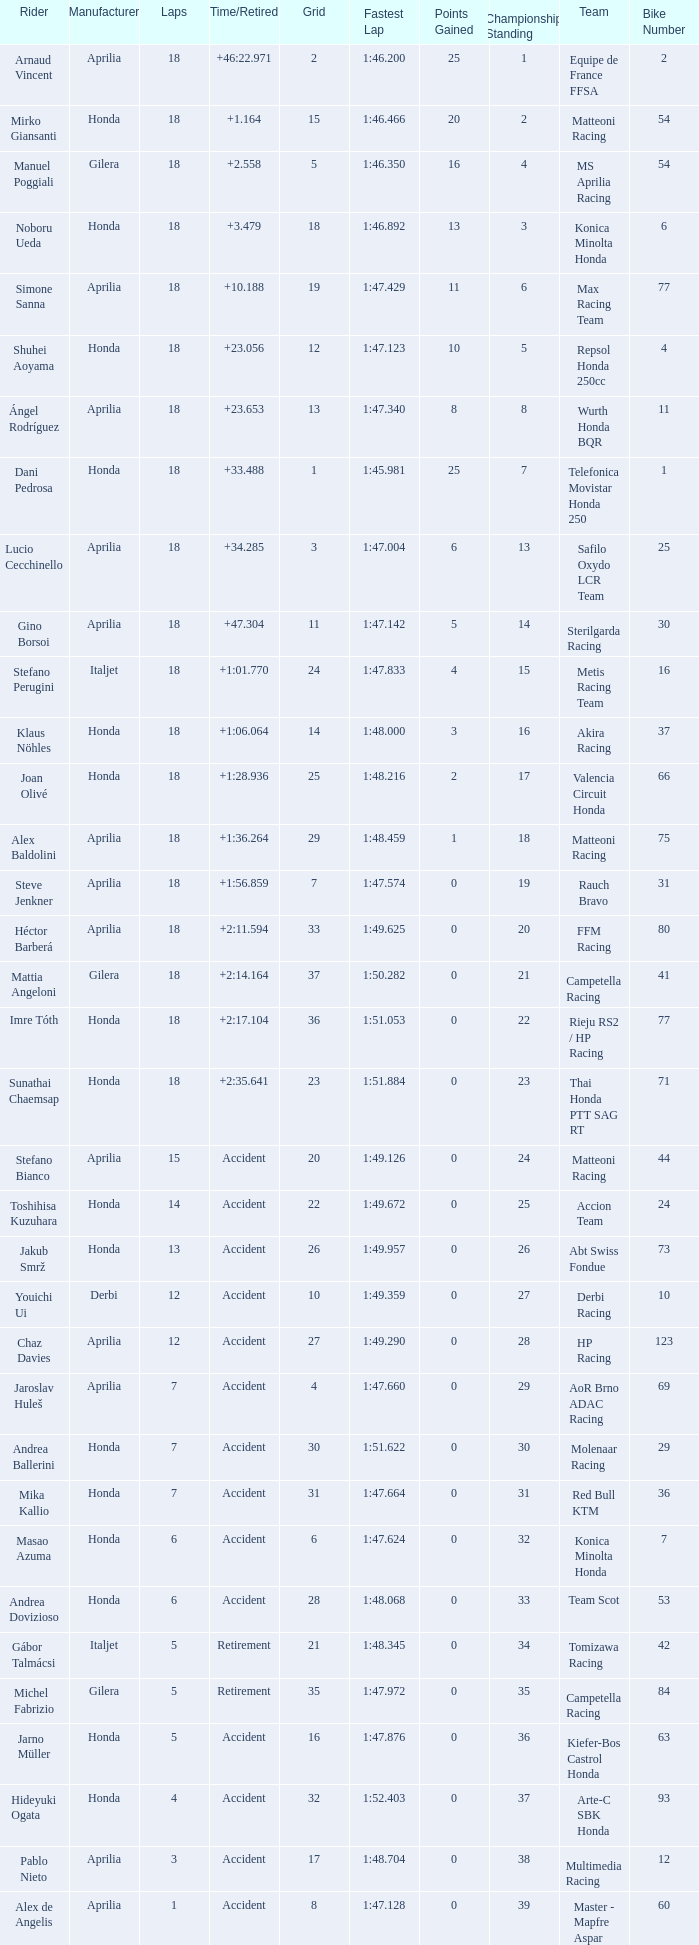Could you parse the entire table as a dict? {'header': ['Rider', 'Manufacturer', 'Laps', 'Time/Retired', 'Grid', 'Fastest Lap', 'Points Gained', 'Championship Standing', 'Team', 'Bike Number'], 'rows': [['Arnaud Vincent', 'Aprilia', '18', '+46:22.971', '2', '1:46.200', '25', '1', 'Equipe de France FFSA', '2'], ['Mirko Giansanti', 'Honda', '18', '+1.164', '15', '1:46.466', '20', '2', 'Matteoni Racing', '54'], ['Manuel Poggiali', 'Gilera', '18', '+2.558', '5', '1:46.350', '16', '4', 'MS Aprilia Racing', '54'], ['Noboru Ueda', 'Honda', '18', '+3.479', '18', '1:46.892', '13', '3', 'Konica Minolta Honda', '6'], ['Simone Sanna', 'Aprilia', '18', '+10.188', '19', '1:47.429', '11', '6', 'Max Racing Team', '77'], ['Shuhei Aoyama', 'Honda', '18', '+23.056', '12', '1:47.123', '10', '5', 'Repsol Honda 250cc', '4'], ['Ángel Rodríguez', 'Aprilia', '18', '+23.653', '13', '1:47.340', '8', '8', 'Wurth Honda BQR', '11'], ['Dani Pedrosa', 'Honda', '18', '+33.488', '1', '1:45.981', '25', '7', 'Telefonica Movistar Honda 250', '1'], ['Lucio Cecchinello', 'Aprilia', '18', '+34.285', '3', '1:47.004', '6', '13', 'Safilo Oxydo LCR Team', '25'], ['Gino Borsoi', 'Aprilia', '18', '+47.304', '11', '1:47.142', '5', '14', 'Sterilgarda Racing', '30'], ['Stefano Perugini', 'Italjet', '18', '+1:01.770', '24', '1:47.833', '4', '15', 'Metis Racing Team', '16'], ['Klaus Nöhles', 'Honda', '18', '+1:06.064', '14', '1:48.000', '3', '16', 'Akira Racing', '37'], ['Joan Olivé', 'Honda', '18', '+1:28.936', '25', '1:48.216', '2', '17', 'Valencia Circuit Honda', '66'], ['Alex Baldolini', 'Aprilia', '18', '+1:36.264', '29', '1:48.459', '1', '18', 'Matteoni Racing', '75'], ['Steve Jenkner', 'Aprilia', '18', '+1:56.859', '7', '1:47.574', '0', '19', 'Rauch Bravo', '31'], ['Héctor Barberá', 'Aprilia', '18', '+2:11.594', '33', '1:49.625', '0', '20', 'FFM Racing', '80'], ['Mattia Angeloni', 'Gilera', '18', '+2:14.164', '37', '1:50.282', '0', '21', 'Campetella Racing', '41'], ['Imre Tóth', 'Honda', '18', '+2:17.104', '36', '1:51.053', '0', '22', 'Rieju RS2 / HP Racing', '77'], ['Sunathai Chaemsap', 'Honda', '18', '+2:35.641', '23', '1:51.884', '0', '23', 'Thai Honda PTT SAG RT', '71'], ['Stefano Bianco', 'Aprilia', '15', 'Accident', '20', '1:49.126', '0', '24', 'Matteoni Racing', '44'], ['Toshihisa Kuzuhara', 'Honda', '14', 'Accident', '22', '1:49.672', '0', '25', 'Accion Team', '24'], ['Jakub Smrž', 'Honda', '13', 'Accident', '26', '1:49.957', '0', '26', 'Abt Swiss Fondue', '73'], ['Youichi Ui', 'Derbi', '12', 'Accident', '10', '1:49.359', '0', '27', 'Derbi Racing', '10'], ['Chaz Davies', 'Aprilia', '12', 'Accident', '27', '1:49.290', '0', '28', 'HP Racing', '123'], ['Jaroslav Huleš', 'Aprilia', '7', 'Accident', '4', '1:47.660', '0', '29', 'AoR Brno ADAC Racing', '69'], ['Andrea Ballerini', 'Honda', '7', 'Accident', '30', '1:51.622', '0', '30', 'Molenaar Racing', '29'], ['Mika Kallio', 'Honda', '7', 'Accident', '31', '1:47.664', '0', '31', 'Red Bull KTM', '36'], ['Masao Azuma', 'Honda', '6', 'Accident', '6', '1:47.624', '0', '32', 'Konica Minolta Honda', '7'], ['Andrea Dovizioso', 'Honda', '6', 'Accident', '28', '1:48.068', '0', '33', 'Team Scot', '53'], ['Gábor Talmácsi', 'Italjet', '5', 'Retirement', '21', '1:48.345', '0', '34', 'Tomizawa Racing', '42'], ['Michel Fabrizio', 'Gilera', '5', 'Retirement', '35', '1:47.972', '0', '35', 'Campetella Racing', '84'], ['Jarno Müller', 'Honda', '5', 'Accident', '16', '1:47.876', '0', '36', 'Kiefer-Bos Castrol Honda', '63'], ['Hideyuki Ogata', 'Honda', '4', 'Accident', '32', '1:52.403', '0', '37', 'Arte-C SBK Honda', '93'], ['Pablo Nieto', 'Aprilia', '3', 'Accident', '17', '1:48.704', '0', '38', 'Multimedia Racing', '12'], ['Alex de Angelis', 'Aprilia', '1', 'Accident', '8', '1:47.128', '0', '39', 'Master - Mapfre Aspar', '60'], ['Max Sabbatani', 'Aprilia', '0', 'Accident', '9', '-', '0', '40', 'Wurth Honda BQR', '14'], ['Akira Komuro', 'Honda', '0', 'Accident', '34', '-', '0', '41', 'Koide Racing', '96']]} Who is the rider with less than 15 laps, more than 32 grids, and an accident time/retired? Akira Komuro. 